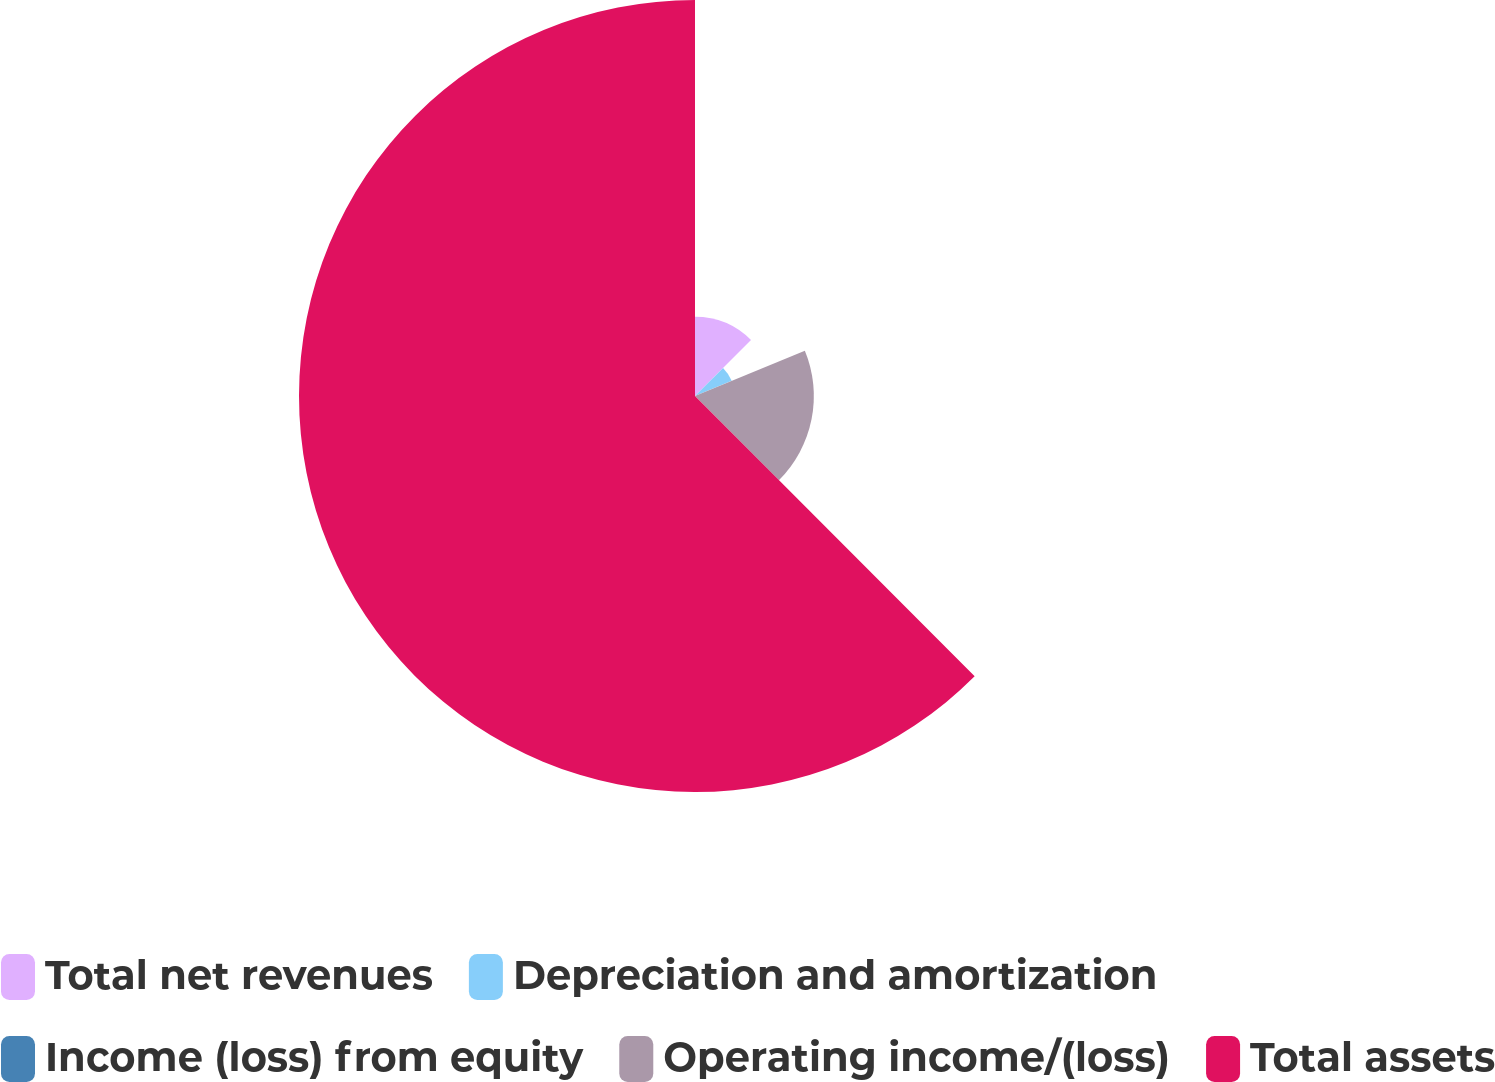Convert chart. <chart><loc_0><loc_0><loc_500><loc_500><pie_chart><fcel>Total net revenues<fcel>Depreciation and amortization<fcel>Income (loss) from equity<fcel>Operating income/(loss)<fcel>Total assets<nl><fcel>12.5%<fcel>6.26%<fcel>0.01%<fcel>18.75%<fcel>62.48%<nl></chart> 